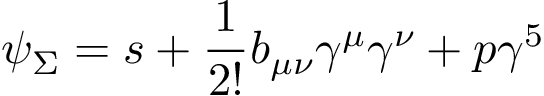Convert formula to latex. <formula><loc_0><loc_0><loc_500><loc_500>\psi _ { \Sigma } = s + \frac { 1 } { 2 ! } b _ { \mu \nu } \gamma ^ { \mu } \gamma ^ { \nu } + p \gamma ^ { 5 }</formula> 